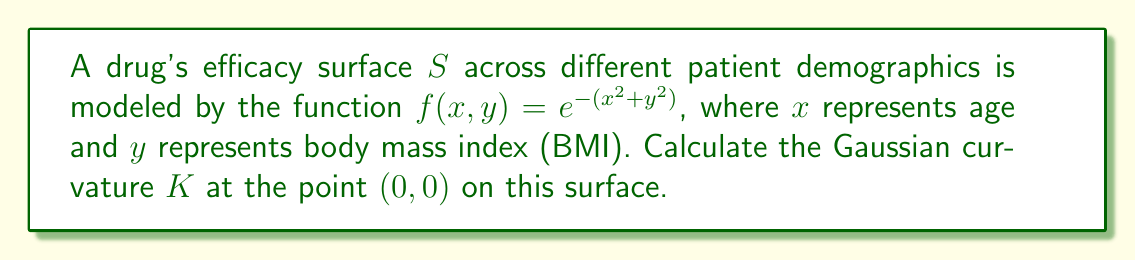Teach me how to tackle this problem. To find the Gaussian curvature $K$ at the point $(0,0)$, we need to follow these steps:

1) The Gaussian curvature is given by $K = \frac{LN - M^2}{EG - F^2}$, where $L$, $M$, $N$ are the coefficients of the second fundamental form, and $E$, $F$, $G$ are the coefficients of the first fundamental form.

2) First, let's calculate the partial derivatives:
   $f_x = -2xe^{-(x^2+y^2)}$
   $f_y = -2ye^{-(x^2+y^2)}$
   $f_{xx} = (-2+4x^2)e^{-(x^2+y^2)}$
   $f_{yy} = (-2+4y^2)e^{-(x^2+y^2)}$
   $f_{xy} = 4xye^{-(x^2+y^2)}$

3) At the point $(0,0)$:
   $f_x(0,0) = 0$
   $f_y(0,0) = 0$
   $f_{xx}(0,0) = -2$
   $f_{yy}(0,0) = -2$
   $f_{xy}(0,0) = 0$

4) The unit normal vector at $(0,0)$ is:
   $$\vec{n} = \frac{(-f_x, -f_y, 1)}{\sqrt{f_x^2 + f_y^2 + 1}} = (0, 0, 1)$$

5) Now we can calculate the coefficients:
   $E = 1 + f_x^2 = 1$
   $F = f_x f_y = 0$
   $G = 1 + f_y^2 = 1$
   $L = f_{xx} \cdot n_z = -2$
   $M = f_{xy} \cdot n_z = 0$
   $N = f_{yy} \cdot n_z = -2$

6) Finally, we can compute the Gaussian curvature:
   $$K = \frac{LN - M^2}{EG - F^2} = \frac{(-2)(-2) - 0^2}{(1)(1) - 0^2} = 4$$

Therefore, the Gaussian curvature at the point $(0,0)$ is 4.
Answer: $K = 4$ 